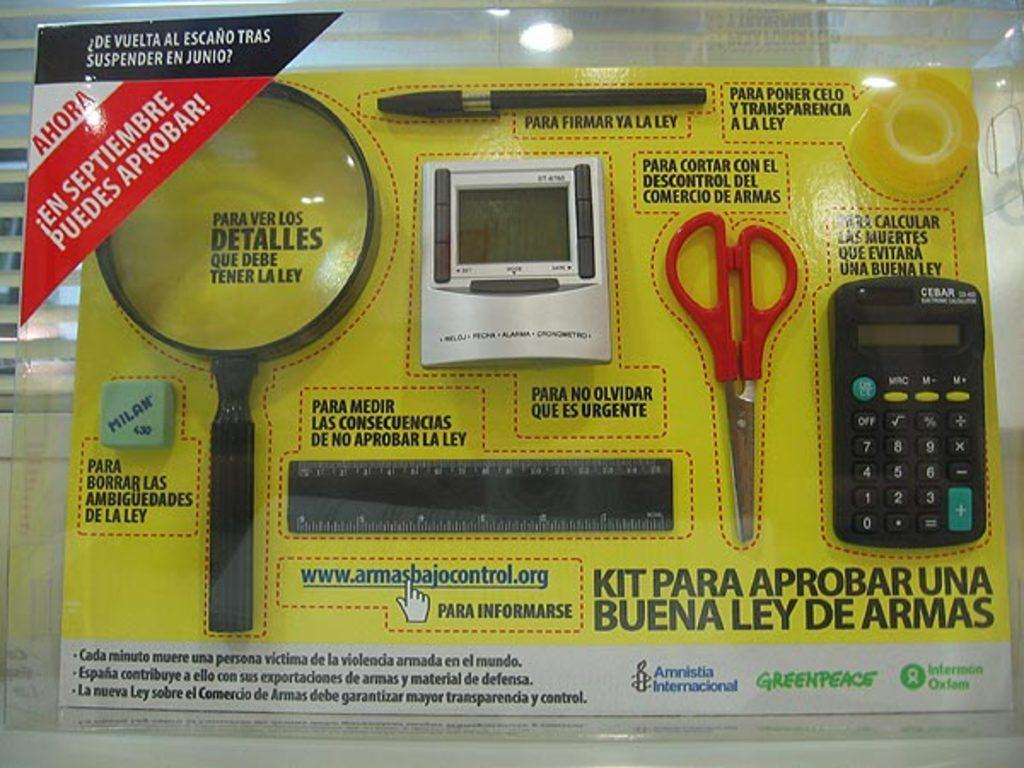What is in the packet that is visible in the image? The packet contains an eraser, a magnifying glass, a pen, scissors, a scale, a calculator, insulation tape, and a digital object. What type of digital object is present in the packet? The specific type of digital object is not mentioned in the facts, but it is present in the packet. What is the purpose of the magnifying glass in the packet? The magnifying glass can be used for magnifying small objects or text. What is the purpose of the insulation tape in the packet? The insulation tape can be used for sealing, insulating, or repairing items. How many friends are visible in the image? There are no friends visible in the image; it only shows a packet with various items inside. What type of brass object is present in the image? There is no brass object present in the image. 